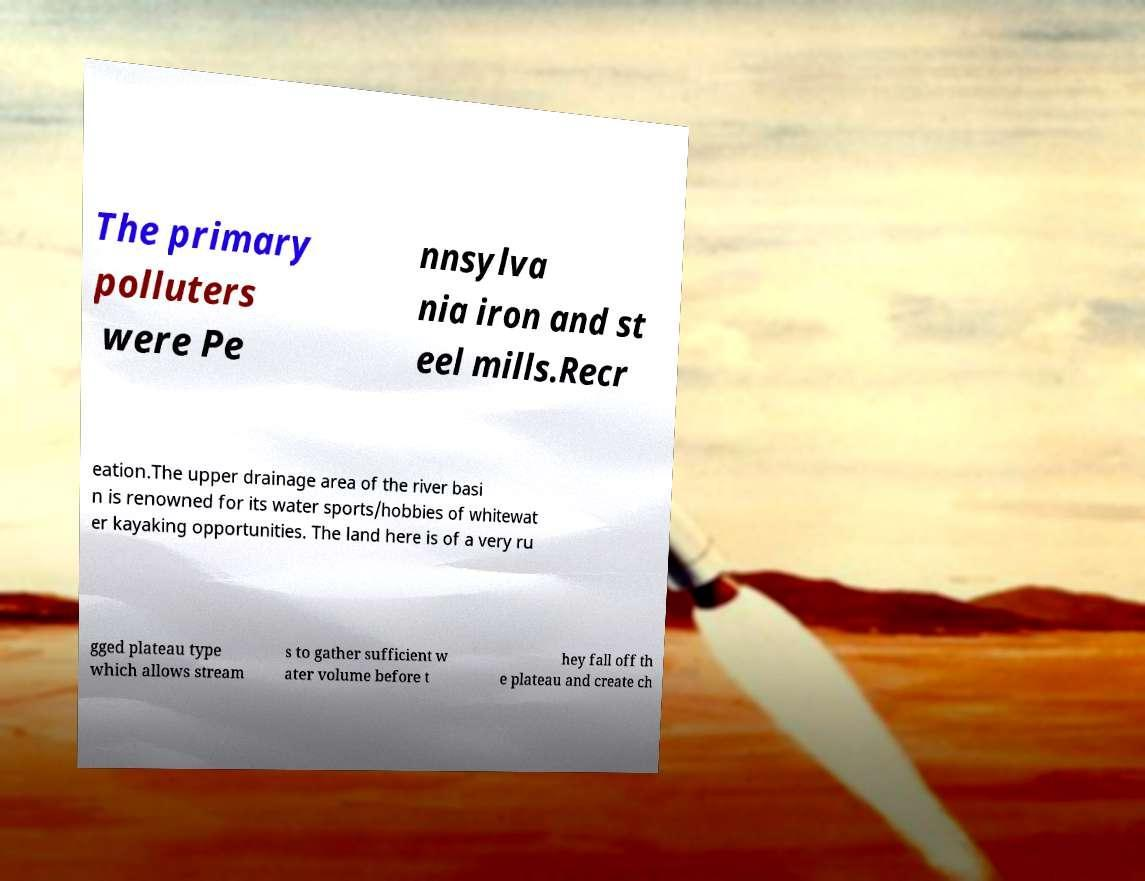I need the written content from this picture converted into text. Can you do that? The primary polluters were Pe nnsylva nia iron and st eel mills.Recr eation.The upper drainage area of the river basi n is renowned for its water sports/hobbies of whitewat er kayaking opportunities. The land here is of a very ru gged plateau type which allows stream s to gather sufficient w ater volume before t hey fall off th e plateau and create ch 